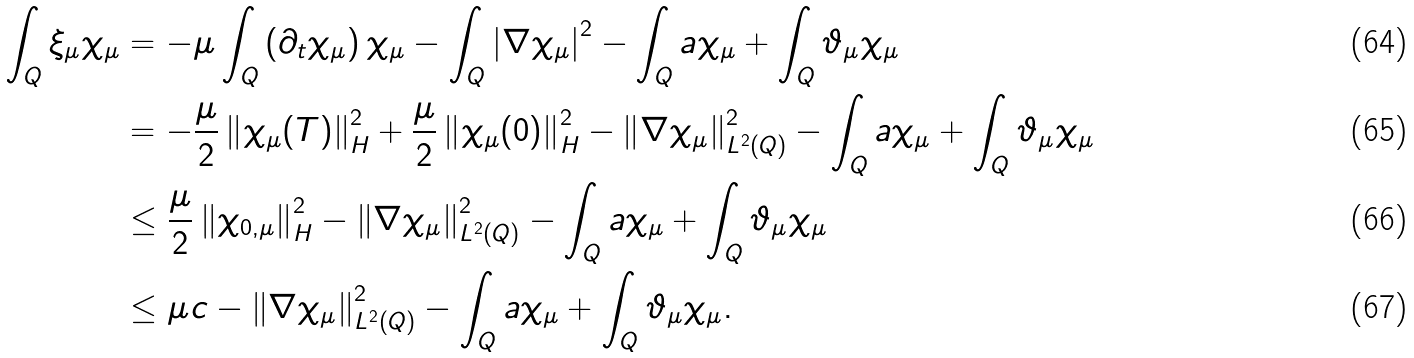<formula> <loc_0><loc_0><loc_500><loc_500>\int _ { Q } { \xi _ { \mu } \chi _ { \mu } } & = - \mu \int _ { Q } { \left ( \partial _ { t } \chi _ { \mu } \right ) \chi _ { \mu } } - \int _ { Q } { \left | \nabla \chi _ { \mu } \right | ^ { 2 } } - \int _ { Q } { a \chi _ { \mu } } + \int _ { Q } { \vartheta _ { \mu } \chi _ { \mu } } \\ & = - \frac { \mu } { 2 } \left \| \chi _ { \mu } ( T ) \right \| ^ { 2 } _ { H } + \frac { \mu } { 2 } \left \| \chi _ { \mu } ( 0 ) \right \| ^ { 2 } _ { H } - \left \| \nabla \chi _ { \mu } \right \| ^ { 2 } _ { L ^ { 2 } ( Q ) } - \int _ { Q } { a \chi _ { \mu } } + \int _ { Q } { \vartheta _ { \mu } \chi _ { \mu } } \\ & \leq \frac { \mu } { 2 } \left \| \chi _ { 0 , \mu } \right \| ^ { 2 } _ { H } - \left \| \nabla \chi _ { \mu } \right \| ^ { 2 } _ { L ^ { 2 } ( Q ) } - \int _ { Q } { a \chi _ { \mu } } + \int _ { Q } { \vartheta _ { \mu } \chi _ { \mu } } \\ & \leq \mu c - \left \| \nabla \chi _ { \mu } \right \| ^ { 2 } _ { L ^ { 2 } ( Q ) } - \int _ { Q } { a \chi _ { \mu } } + \int _ { Q } { \vartheta _ { \mu } \chi _ { \mu } } .</formula> 